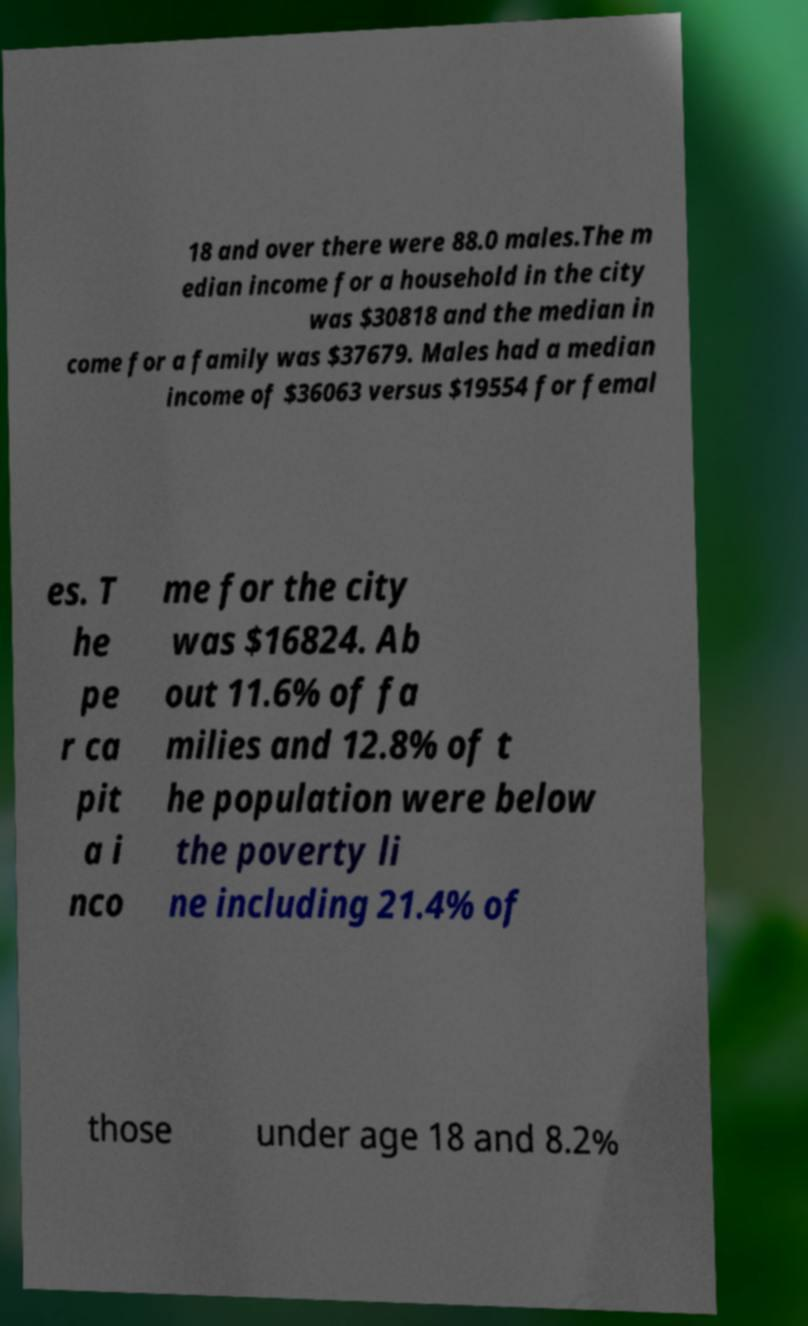Can you read and provide the text displayed in the image?This photo seems to have some interesting text. Can you extract and type it out for me? 18 and over there were 88.0 males.The m edian income for a household in the city was $30818 and the median in come for a family was $37679. Males had a median income of $36063 versus $19554 for femal es. T he pe r ca pit a i nco me for the city was $16824. Ab out 11.6% of fa milies and 12.8% of t he population were below the poverty li ne including 21.4% of those under age 18 and 8.2% 